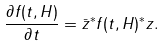<formula> <loc_0><loc_0><loc_500><loc_500>\frac { \partial f ( t , H ) } { \partial t } = { \bar { z } } ^ { * } f ( t , H ) ^ { * } z .</formula> 